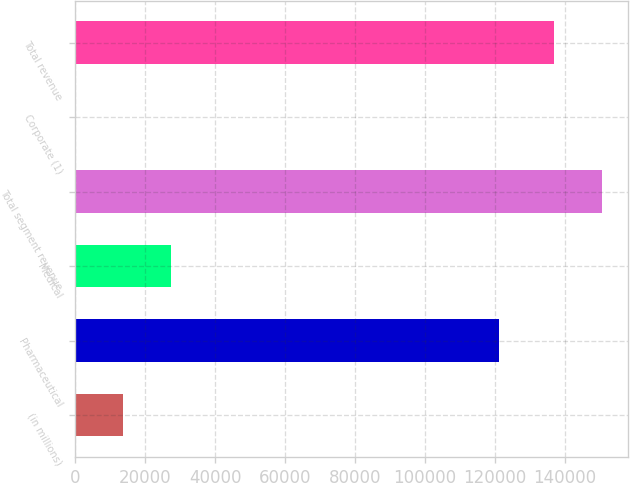<chart> <loc_0><loc_0><loc_500><loc_500><bar_chart><fcel>(in millions)<fcel>Pharmaceutical<fcel>Medical<fcel>Total segment revenue<fcel>Corporate (1)<fcel>Total revenue<nl><fcel>13693.9<fcel>121241<fcel>27374.8<fcel>150490<fcel>13<fcel>136809<nl></chart> 